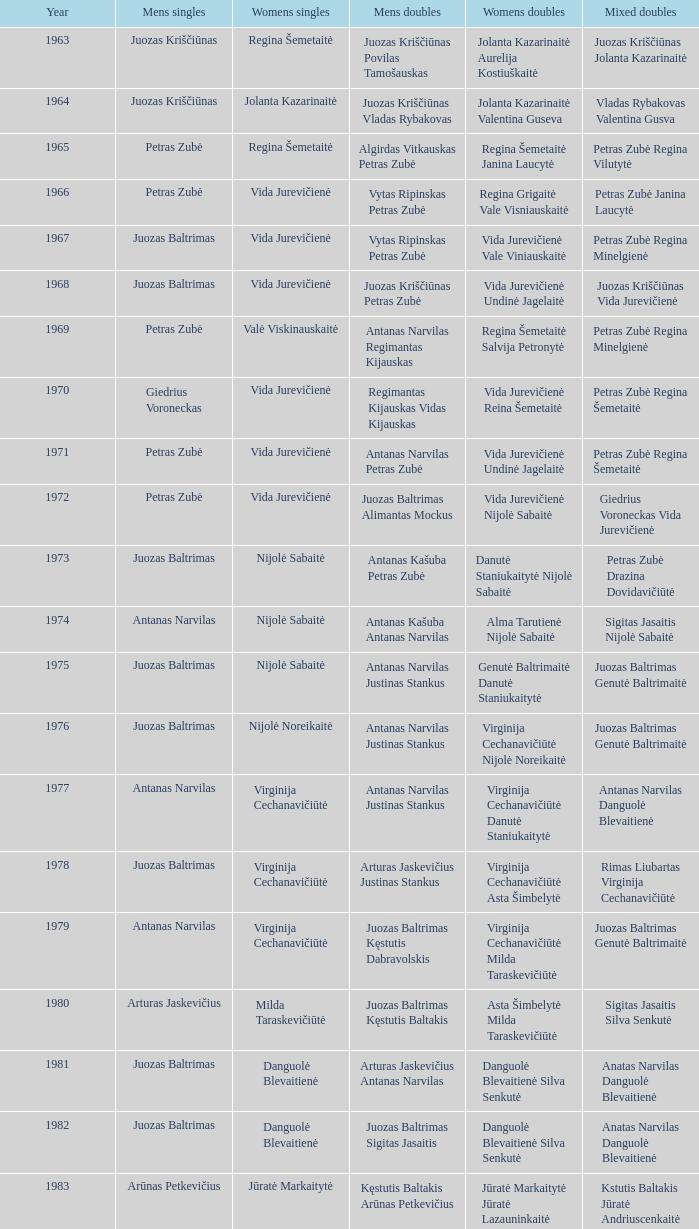Over how many years did aivaras kvedarauskas and juozas spelveris compete in men's doubles matches? 1.0. 